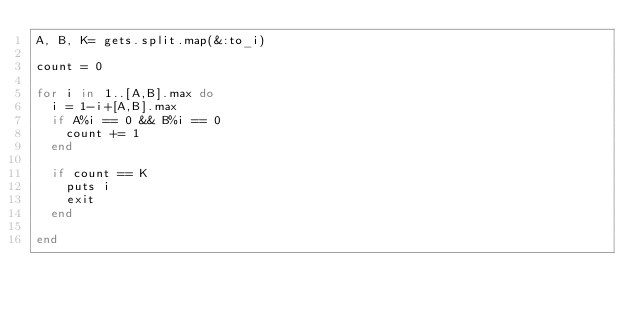Convert code to text. <code><loc_0><loc_0><loc_500><loc_500><_Ruby_>A, B, K= gets.split.map(&:to_i)

count = 0

for i in 1..[A,B].max do
  i = 1-i+[A,B].max
  if A%i == 0 && B%i == 0
    count += 1
  end

  if count == K
    puts i
    exit
  end

end
</code> 